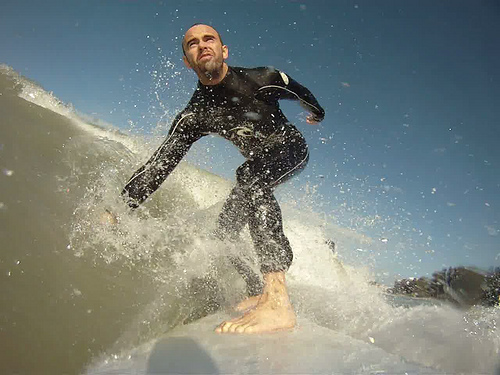Identify different aspects of the surfer's attire and how they contribute to his performance. The surfer's attire, primarily his black wetsuit, is crucial for both comfort and performance. The wetsuit is designed to provide insulation, keeping him warm in the potentially cool ocean water, which is essential for maintaining optimal physical performance. The sleek, form-fitting material reduces drag, allowing for smoother and more efficient movement through the water. Additionally, the wetsuit offers protection against abrasions from the surfboard and potential marine hazards. His barefoot stance maximizes his grip and control on the board, crucial for the precise maneuvers necessary in surfing. What safety equipment might the surfer be using that isn't visible in the image? While not visible in the image, the surfer may be using additional safety equipment such as a leash, which attaches his ankle to the surfboard to prevent the board from drifting away after a fall. He may also be using wax on the surfboard to increase traction and prevent slipping. Depending on his preference or the surf location, he might have a helmet for head protection or a personal flotation device (PFD) for additional buoyancy, though these are less common for experienced surfers. If this scene were part of a movie, what backstory could led up to this dramatic moment? In the context of a movie, the backstory to this dramatic surf scene could involve the surfer as a seasoned professional on a quest to find the ultimate wave. He's traveled the world, from the glistening beaches of Hawaii to the rugged coastlines of Portugal, each location presenting new challenges and stories. This day, he is confronting a significant personal milestone—perhaps overcoming a fear from a past surfing accident or preparing for an upcoming championship. Each wave ridden is not just a test of skill but a journey of self-discovery, resilience, and passion. This particular wave, captured in the image, represents a pivotal moment of triumph and the culmination of years of dedication, dreams, and relentless pursuit of excellence. 